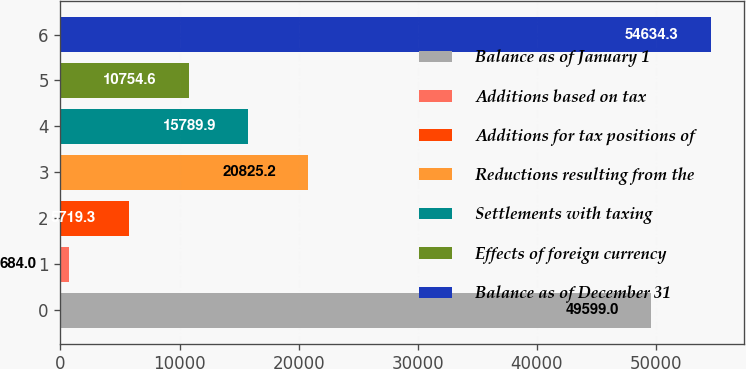Convert chart to OTSL. <chart><loc_0><loc_0><loc_500><loc_500><bar_chart><fcel>Balance as of January 1<fcel>Additions based on tax<fcel>Additions for tax positions of<fcel>Reductions resulting from the<fcel>Settlements with taxing<fcel>Effects of foreign currency<fcel>Balance as of December 31<nl><fcel>49599<fcel>684<fcel>5719.3<fcel>20825.2<fcel>15789.9<fcel>10754.6<fcel>54634.3<nl></chart> 